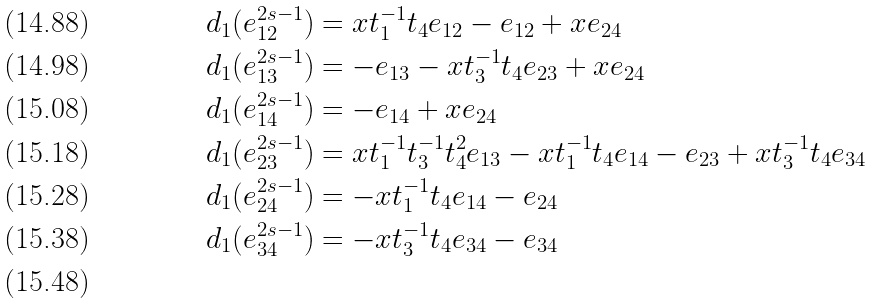<formula> <loc_0><loc_0><loc_500><loc_500>d _ { 1 } ( e _ { 1 2 } ^ { 2 s - 1 } ) & = x t _ { 1 } ^ { - 1 } t _ { 4 } e _ { 1 2 } - e _ { 1 2 } + x e _ { 2 4 } \\ d _ { 1 } ( e _ { 1 3 } ^ { 2 s - 1 } ) & = - e _ { 1 3 } - x t _ { 3 } ^ { - 1 } t _ { 4 } e _ { 2 3 } + x e _ { 2 4 } \\ d _ { 1 } ( e _ { 1 4 } ^ { 2 s - 1 } ) & = - e _ { 1 4 } + x e _ { 2 4 } \\ d _ { 1 } ( e _ { 2 3 } ^ { 2 s - 1 } ) & = x t _ { 1 } ^ { - 1 } t _ { 3 } ^ { - 1 } t _ { 4 } ^ { 2 } e _ { 1 3 } - x t _ { 1 } ^ { - 1 } t _ { 4 } e _ { 1 4 } - e _ { 2 3 } + x t _ { 3 } ^ { - 1 } t _ { 4 } e _ { 3 4 } \\ d _ { 1 } ( e _ { 2 4 } ^ { 2 s - 1 } ) & = - x t _ { 1 } ^ { - 1 } t _ { 4 } e _ { 1 4 } - e _ { 2 4 } \\ d _ { 1 } ( e _ { 3 4 } ^ { 2 s - 1 } ) & = - x t _ { 3 } ^ { - 1 } t _ { 4 } e _ { 3 4 } - e _ { 3 4 } \\</formula> 